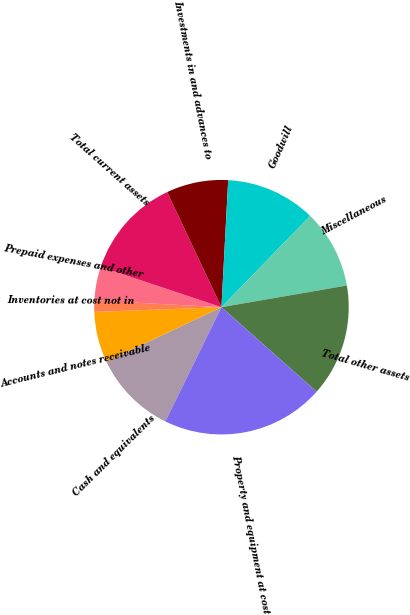<chart> <loc_0><loc_0><loc_500><loc_500><pie_chart><fcel>Cash and equivalents<fcel>Accounts and notes receivable<fcel>Inventories at cost not in<fcel>Prepaid expenses and other<fcel>Total current assets<fcel>Investments in and advances to<fcel>Goodwill<fcel>Miscellaneous<fcel>Total other assets<fcel>Property and equipment at cost<nl><fcel>10.71%<fcel>6.43%<fcel>1.43%<fcel>4.29%<fcel>12.86%<fcel>7.86%<fcel>11.43%<fcel>10.0%<fcel>14.28%<fcel>20.71%<nl></chart> 